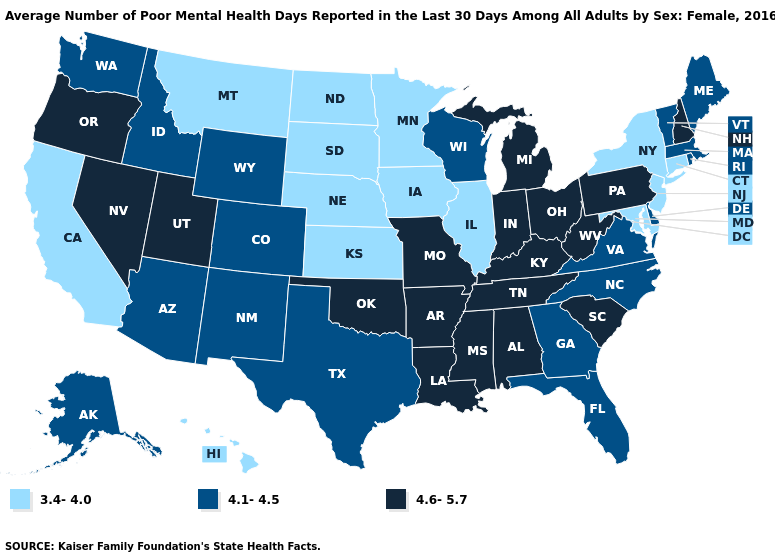What is the value of Utah?
Short answer required. 4.6-5.7. Which states have the lowest value in the USA?
Be succinct. California, Connecticut, Hawaii, Illinois, Iowa, Kansas, Maryland, Minnesota, Montana, Nebraska, New Jersey, New York, North Dakota, South Dakota. Does South Dakota have the highest value in the USA?
Answer briefly. No. Which states have the lowest value in the USA?
Keep it brief. California, Connecticut, Hawaii, Illinois, Iowa, Kansas, Maryland, Minnesota, Montana, Nebraska, New Jersey, New York, North Dakota, South Dakota. Does Kansas have the lowest value in the USA?
Write a very short answer. Yes. What is the value of New York?
Be succinct. 3.4-4.0. Name the states that have a value in the range 3.4-4.0?
Keep it brief. California, Connecticut, Hawaii, Illinois, Iowa, Kansas, Maryland, Minnesota, Montana, Nebraska, New Jersey, New York, North Dakota, South Dakota. What is the highest value in the MidWest ?
Keep it brief. 4.6-5.7. Name the states that have a value in the range 4.6-5.7?
Be succinct. Alabama, Arkansas, Indiana, Kentucky, Louisiana, Michigan, Mississippi, Missouri, Nevada, New Hampshire, Ohio, Oklahoma, Oregon, Pennsylvania, South Carolina, Tennessee, Utah, West Virginia. Does the map have missing data?
Quick response, please. No. Does Michigan have the lowest value in the MidWest?
Be succinct. No. What is the highest value in the South ?
Quick response, please. 4.6-5.7. What is the highest value in the USA?
Be succinct. 4.6-5.7. Does Mississippi have the lowest value in the South?
Answer briefly. No. Among the states that border Pennsylvania , does Delaware have the highest value?
Answer briefly. No. 